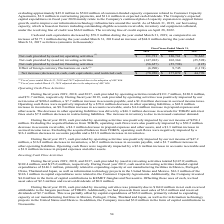From Kemet Corporation's financial document, Which years does the table provide information for the cash and cash equivalents for the company?  The document contains multiple relevant values: 2019, 2018, 2017. From the document: "2019 2018 2017 2019 2018 2017 2019 2018 2017..." Also, What was the Net cash provided by (used in) investing activities in 2018? According to the financial document, 102,364 (in thousands). The relevant text states: "vided by (used in) investing activities (147,012) 102,364 (25,598)..." Also, What was the Net cash provided by (used in) financing activities in 2017? According to the financial document, (125) (in thousands). The relevant text states: "y (used in) financing activities (56,657) (55,798) (125)..." Additionally, Which years did Net cash provided by operating activities exceed $100,000 thousand? The document shows two values: 2019 and 2018. From the document: "2019 2018 2017 2019 2018 2017..." Also, can you calculate: What was the change in Net cash provided by financing activities between 2017 and 2018? Based on the calculation: -55,798-(-125), the result is -55673 (in thousands). This is based on the information: "vided by (used in) financing activities (56,657) (55,798) (125) (used in) financing activities (56,657) (55,798) (125)..." The key data points involved are: 125, 55,798. Also, can you calculate: What was the percentage change in the Net increase in cash, cash equivalents, and restricted cash between 2018 and 2019? To answer this question, I need to perform calculations using the financial data. The calculation is: (-78,928-177,072)/177,072, which equals -144.57 (percentage). This is based on the information: "in cash, cash equivalents, and restricted cash $ (78,928) $ 177,072 $ 44,770 ash equivalents, and restricted cash $ (78,928) $ 177,072 $ 44,770..." The key data points involved are: 177,072, 78,928. 